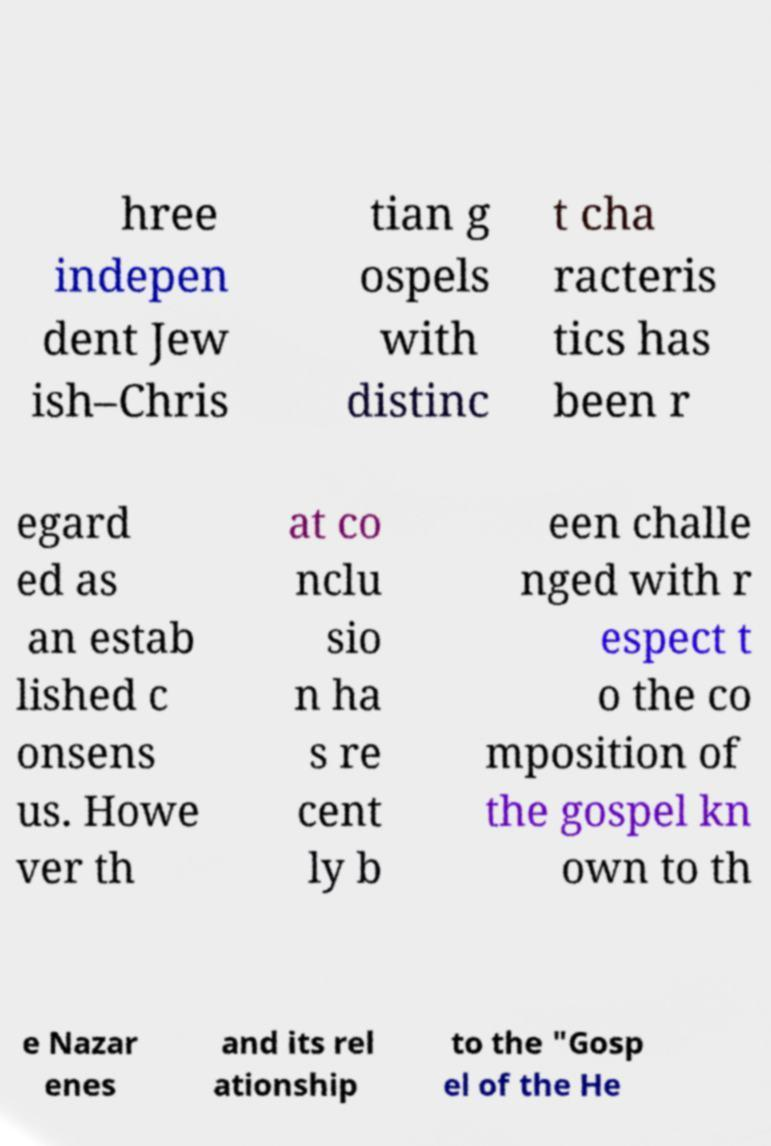Please identify and transcribe the text found in this image. hree indepen dent Jew ish–Chris tian g ospels with distinc t cha racteris tics has been r egard ed as an estab lished c onsens us. Howe ver th at co nclu sio n ha s re cent ly b een challe nged with r espect t o the co mposition of the gospel kn own to th e Nazar enes and its rel ationship to the "Gosp el of the He 